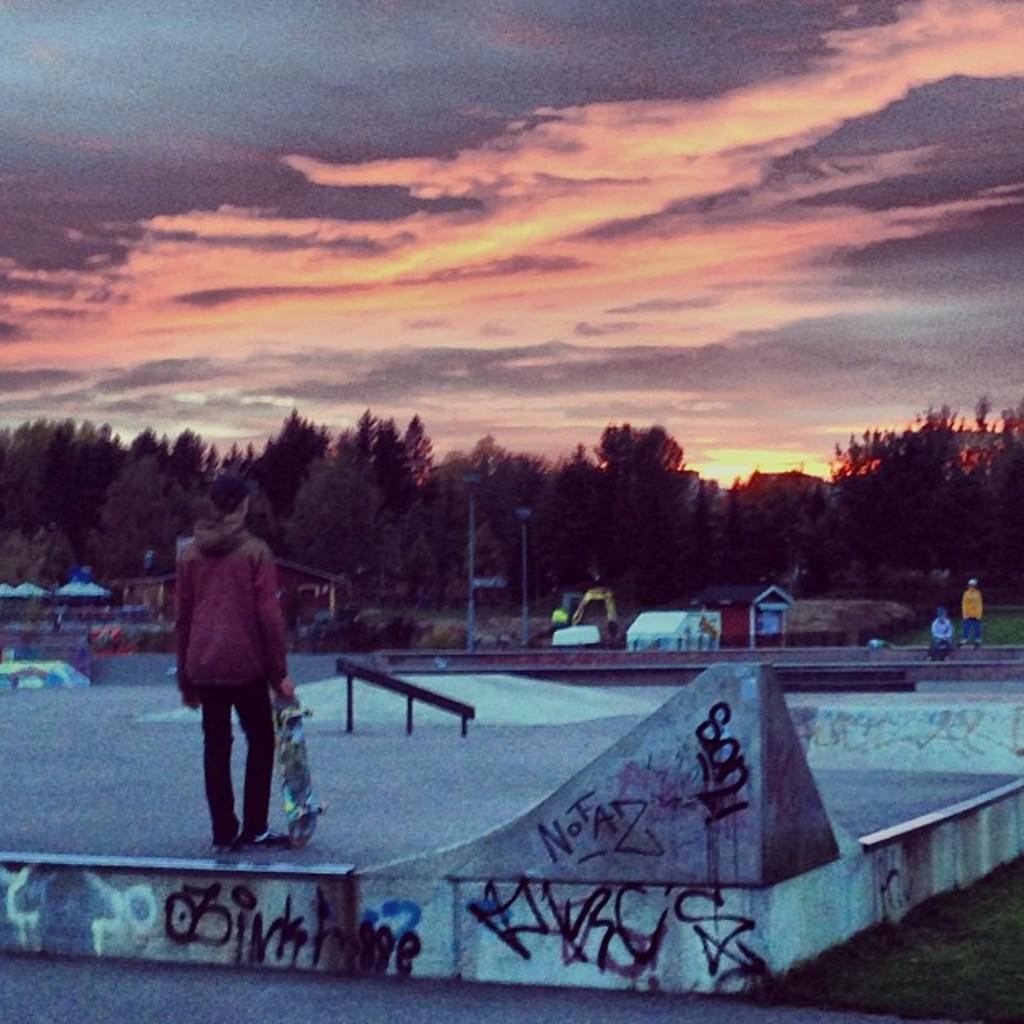Please provide a concise description of this image. In this picture there is a boy on the left side of the image, by holding skateboard in his hand and there are houses, trees, poles, and other people in the background area of the image. 